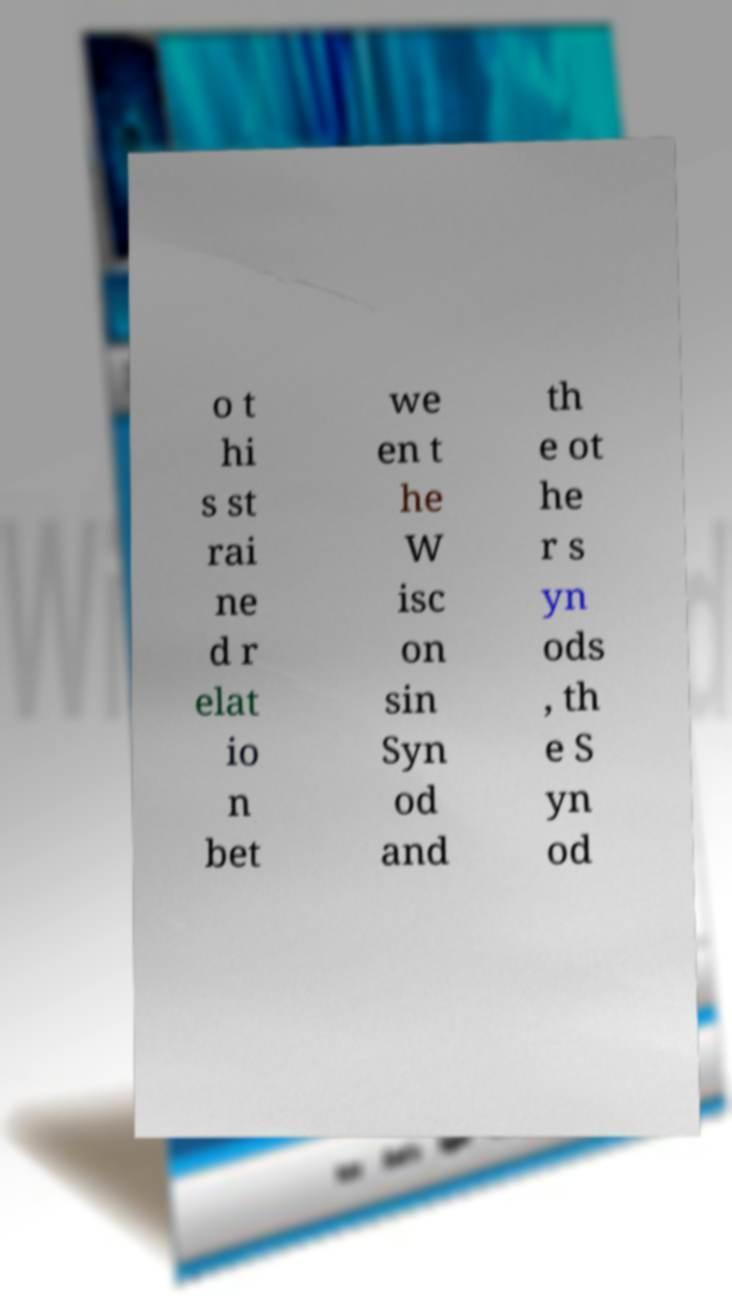What messages or text are displayed in this image? I need them in a readable, typed format. o t hi s st rai ne d r elat io n bet we en t he W isc on sin Syn od and th e ot he r s yn ods , th e S yn od 